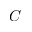Convert formula to latex. <formula><loc_0><loc_0><loc_500><loc_500>C</formula> 